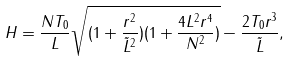Convert formula to latex. <formula><loc_0><loc_0><loc_500><loc_500>H = \frac { N T _ { 0 } } { L } \sqrt { ( 1 + \frac { r ^ { 2 } } { \tilde { L } ^ { 2 } } ) ( 1 + \frac { 4 L ^ { 2 } r ^ { 4 } } { N ^ { 2 } } ) } - \frac { 2 T _ { 0 } r ^ { 3 } } { \tilde { L } } ,</formula> 